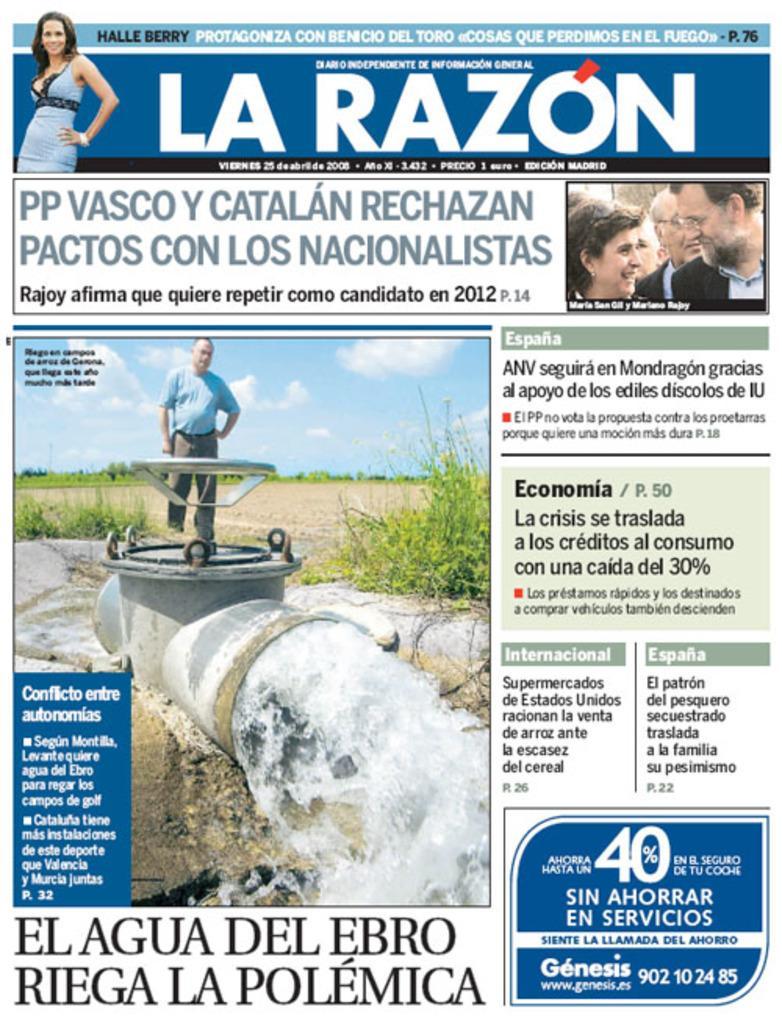Please provide a concise description of this image. In this image I can see few people and one person is standing in front of the pipe and I can see water from the pipe. Back I can see few trees, the grass and the sky is in blue and white color. Something is written on it. 